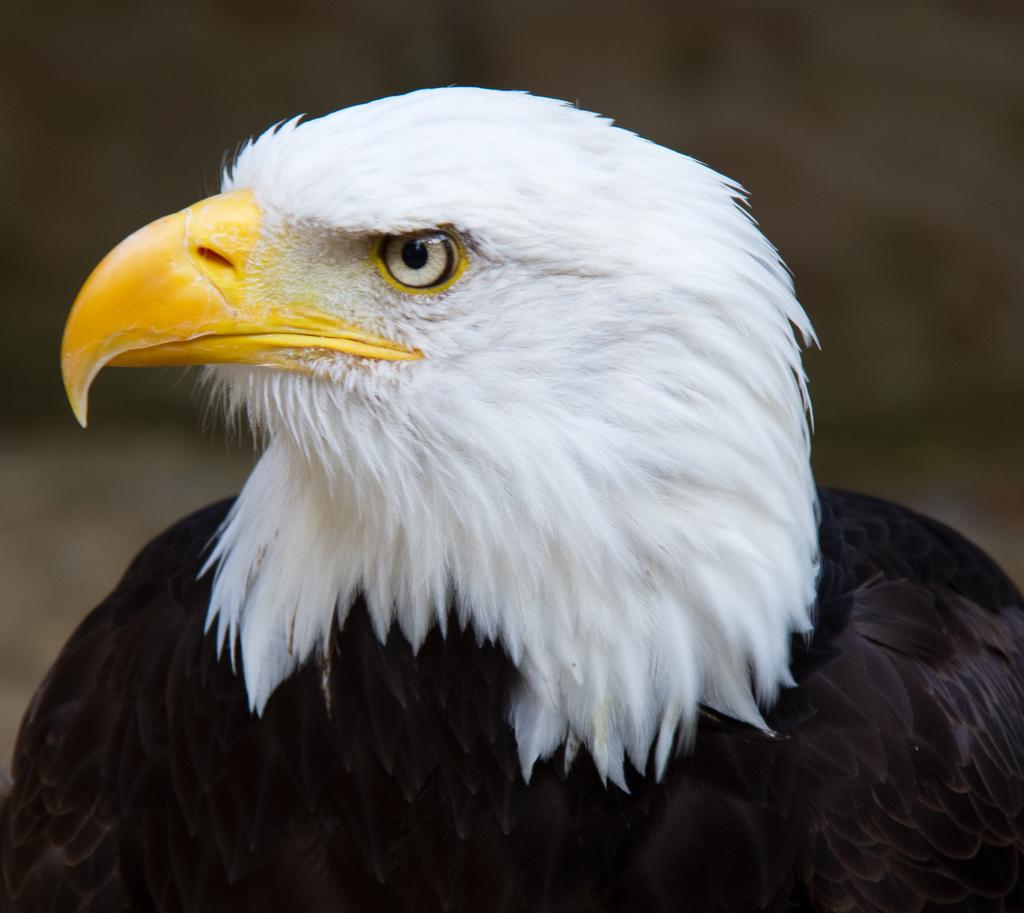What is the main subject of the image? There is a bird in the middle of the image. What color is the background of the image? The background of the image is black. What type of plough is being used by the owl in the image? There is no plough or owl present in the image; it features a bird against a black background. 